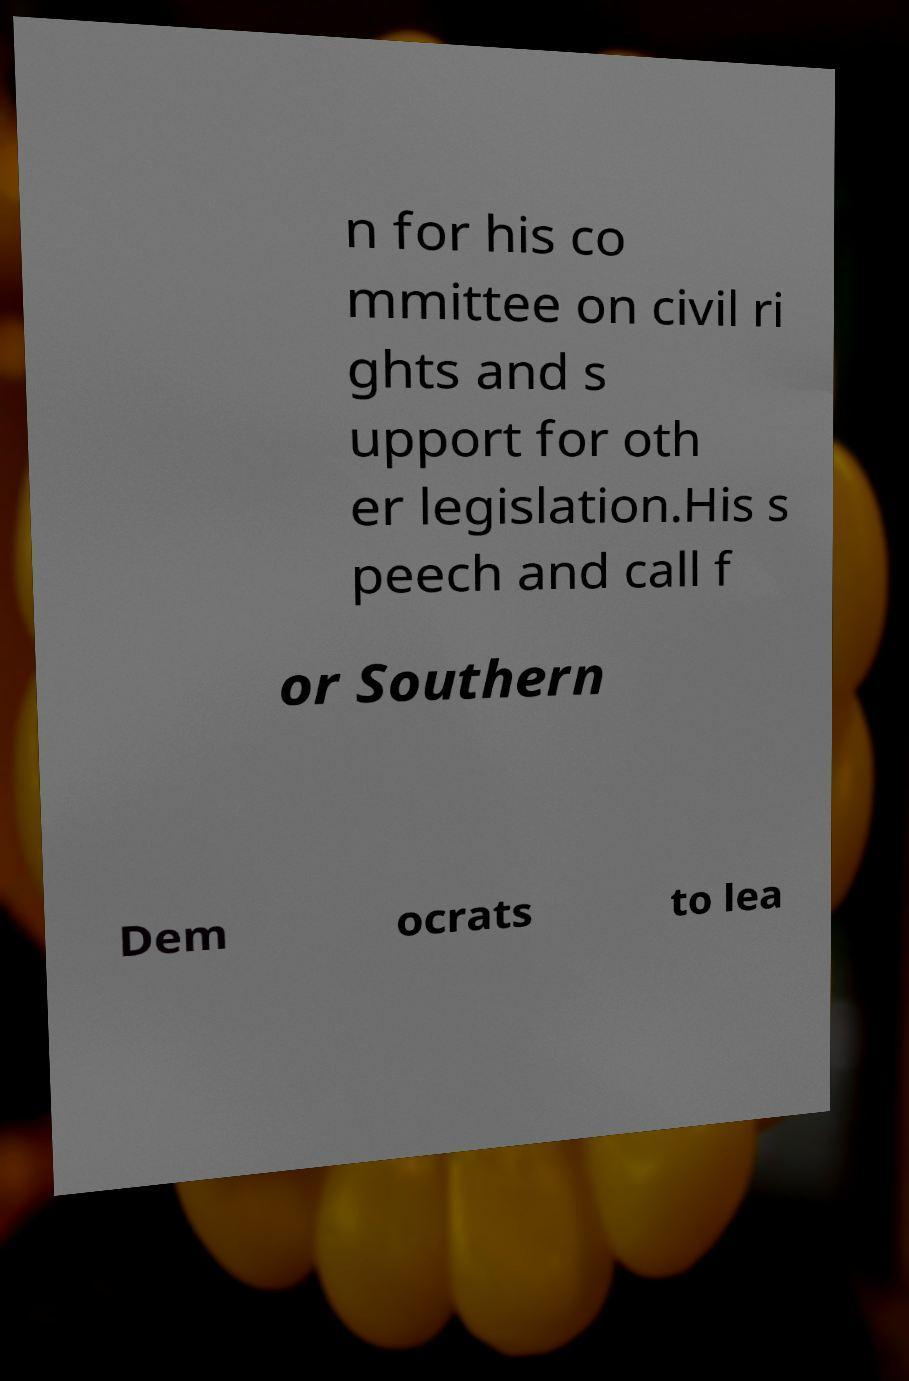For documentation purposes, I need the text within this image transcribed. Could you provide that? n for his co mmittee on civil ri ghts and s upport for oth er legislation.His s peech and call f or Southern Dem ocrats to lea 